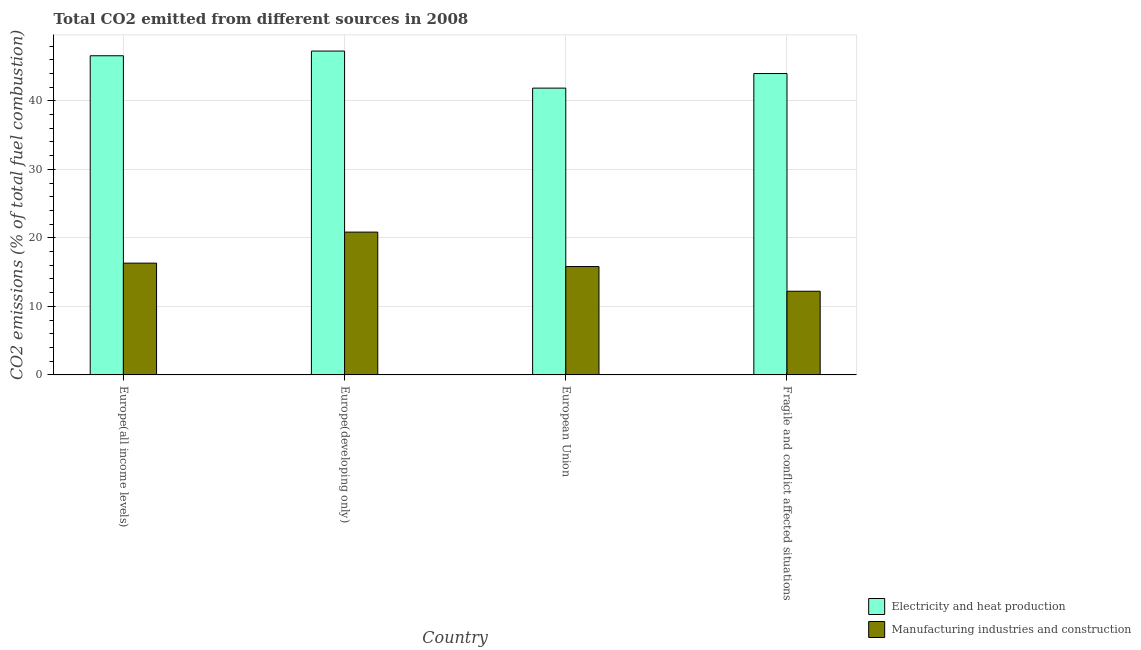How many different coloured bars are there?
Keep it short and to the point. 2. How many groups of bars are there?
Give a very brief answer. 4. Are the number of bars per tick equal to the number of legend labels?
Ensure brevity in your answer.  Yes. Are the number of bars on each tick of the X-axis equal?
Provide a succinct answer. Yes. How many bars are there on the 4th tick from the left?
Provide a succinct answer. 2. What is the label of the 2nd group of bars from the left?
Provide a succinct answer. Europe(developing only). What is the co2 emissions due to manufacturing industries in European Union?
Ensure brevity in your answer.  15.81. Across all countries, what is the maximum co2 emissions due to manufacturing industries?
Provide a succinct answer. 20.84. Across all countries, what is the minimum co2 emissions due to manufacturing industries?
Offer a very short reply. 12.21. In which country was the co2 emissions due to electricity and heat production maximum?
Make the answer very short. Europe(developing only). What is the total co2 emissions due to manufacturing industries in the graph?
Your response must be concise. 65.18. What is the difference between the co2 emissions due to electricity and heat production in Europe(all income levels) and that in European Union?
Provide a succinct answer. 4.72. What is the difference between the co2 emissions due to manufacturing industries in European Union and the co2 emissions due to electricity and heat production in Europe(developing only)?
Offer a terse response. -31.45. What is the average co2 emissions due to manufacturing industries per country?
Offer a terse response. 16.3. What is the difference between the co2 emissions due to electricity and heat production and co2 emissions due to manufacturing industries in Fragile and conflict affected situations?
Give a very brief answer. 31.77. What is the ratio of the co2 emissions due to electricity and heat production in Europe(all income levels) to that in Fragile and conflict affected situations?
Your answer should be compact. 1.06. What is the difference between the highest and the second highest co2 emissions due to electricity and heat production?
Offer a terse response. 0.68. What is the difference between the highest and the lowest co2 emissions due to manufacturing industries?
Provide a short and direct response. 8.63. In how many countries, is the co2 emissions due to electricity and heat production greater than the average co2 emissions due to electricity and heat production taken over all countries?
Your response must be concise. 2. Is the sum of the co2 emissions due to manufacturing industries in Europe(all income levels) and Europe(developing only) greater than the maximum co2 emissions due to electricity and heat production across all countries?
Keep it short and to the point. No. What does the 2nd bar from the left in Europe(developing only) represents?
Provide a succinct answer. Manufacturing industries and construction. What does the 1st bar from the right in Europe(all income levels) represents?
Make the answer very short. Manufacturing industries and construction. Does the graph contain grids?
Offer a very short reply. Yes. Where does the legend appear in the graph?
Give a very brief answer. Bottom right. How are the legend labels stacked?
Your answer should be compact. Vertical. What is the title of the graph?
Provide a succinct answer. Total CO2 emitted from different sources in 2008. What is the label or title of the Y-axis?
Offer a very short reply. CO2 emissions (% of total fuel combustion). What is the CO2 emissions (% of total fuel combustion) in Electricity and heat production in Europe(all income levels)?
Provide a short and direct response. 46.58. What is the CO2 emissions (% of total fuel combustion) of Manufacturing industries and construction in Europe(all income levels)?
Keep it short and to the point. 16.31. What is the CO2 emissions (% of total fuel combustion) of Electricity and heat production in Europe(developing only)?
Your answer should be compact. 47.26. What is the CO2 emissions (% of total fuel combustion) of Manufacturing industries and construction in Europe(developing only)?
Offer a terse response. 20.84. What is the CO2 emissions (% of total fuel combustion) of Electricity and heat production in European Union?
Provide a short and direct response. 41.86. What is the CO2 emissions (% of total fuel combustion) of Manufacturing industries and construction in European Union?
Give a very brief answer. 15.81. What is the CO2 emissions (% of total fuel combustion) of Electricity and heat production in Fragile and conflict affected situations?
Keep it short and to the point. 43.98. What is the CO2 emissions (% of total fuel combustion) of Manufacturing industries and construction in Fragile and conflict affected situations?
Your answer should be very brief. 12.21. Across all countries, what is the maximum CO2 emissions (% of total fuel combustion) of Electricity and heat production?
Your answer should be very brief. 47.26. Across all countries, what is the maximum CO2 emissions (% of total fuel combustion) of Manufacturing industries and construction?
Your answer should be very brief. 20.84. Across all countries, what is the minimum CO2 emissions (% of total fuel combustion) of Electricity and heat production?
Ensure brevity in your answer.  41.86. Across all countries, what is the minimum CO2 emissions (% of total fuel combustion) of Manufacturing industries and construction?
Offer a very short reply. 12.21. What is the total CO2 emissions (% of total fuel combustion) of Electricity and heat production in the graph?
Make the answer very short. 179.68. What is the total CO2 emissions (% of total fuel combustion) in Manufacturing industries and construction in the graph?
Your answer should be compact. 65.18. What is the difference between the CO2 emissions (% of total fuel combustion) of Electricity and heat production in Europe(all income levels) and that in Europe(developing only)?
Make the answer very short. -0.69. What is the difference between the CO2 emissions (% of total fuel combustion) in Manufacturing industries and construction in Europe(all income levels) and that in Europe(developing only)?
Provide a short and direct response. -4.53. What is the difference between the CO2 emissions (% of total fuel combustion) of Electricity and heat production in Europe(all income levels) and that in European Union?
Provide a succinct answer. 4.72. What is the difference between the CO2 emissions (% of total fuel combustion) of Manufacturing industries and construction in Europe(all income levels) and that in European Union?
Offer a terse response. 0.5. What is the difference between the CO2 emissions (% of total fuel combustion) of Electricity and heat production in Europe(all income levels) and that in Fragile and conflict affected situations?
Your response must be concise. 2.6. What is the difference between the CO2 emissions (% of total fuel combustion) in Manufacturing industries and construction in Europe(all income levels) and that in Fragile and conflict affected situations?
Keep it short and to the point. 4.1. What is the difference between the CO2 emissions (% of total fuel combustion) of Electricity and heat production in Europe(developing only) and that in European Union?
Provide a short and direct response. 5.41. What is the difference between the CO2 emissions (% of total fuel combustion) in Manufacturing industries and construction in Europe(developing only) and that in European Union?
Ensure brevity in your answer.  5.03. What is the difference between the CO2 emissions (% of total fuel combustion) of Electricity and heat production in Europe(developing only) and that in Fragile and conflict affected situations?
Offer a very short reply. 3.28. What is the difference between the CO2 emissions (% of total fuel combustion) of Manufacturing industries and construction in Europe(developing only) and that in Fragile and conflict affected situations?
Offer a very short reply. 8.63. What is the difference between the CO2 emissions (% of total fuel combustion) of Electricity and heat production in European Union and that in Fragile and conflict affected situations?
Keep it short and to the point. -2.13. What is the difference between the CO2 emissions (% of total fuel combustion) of Manufacturing industries and construction in European Union and that in Fragile and conflict affected situations?
Provide a short and direct response. 3.6. What is the difference between the CO2 emissions (% of total fuel combustion) in Electricity and heat production in Europe(all income levels) and the CO2 emissions (% of total fuel combustion) in Manufacturing industries and construction in Europe(developing only)?
Provide a short and direct response. 25.74. What is the difference between the CO2 emissions (% of total fuel combustion) in Electricity and heat production in Europe(all income levels) and the CO2 emissions (% of total fuel combustion) in Manufacturing industries and construction in European Union?
Your response must be concise. 30.77. What is the difference between the CO2 emissions (% of total fuel combustion) in Electricity and heat production in Europe(all income levels) and the CO2 emissions (% of total fuel combustion) in Manufacturing industries and construction in Fragile and conflict affected situations?
Your response must be concise. 34.37. What is the difference between the CO2 emissions (% of total fuel combustion) of Electricity and heat production in Europe(developing only) and the CO2 emissions (% of total fuel combustion) of Manufacturing industries and construction in European Union?
Your answer should be very brief. 31.45. What is the difference between the CO2 emissions (% of total fuel combustion) of Electricity and heat production in Europe(developing only) and the CO2 emissions (% of total fuel combustion) of Manufacturing industries and construction in Fragile and conflict affected situations?
Offer a terse response. 35.05. What is the difference between the CO2 emissions (% of total fuel combustion) in Electricity and heat production in European Union and the CO2 emissions (% of total fuel combustion) in Manufacturing industries and construction in Fragile and conflict affected situations?
Provide a succinct answer. 29.64. What is the average CO2 emissions (% of total fuel combustion) of Electricity and heat production per country?
Your response must be concise. 44.92. What is the average CO2 emissions (% of total fuel combustion) of Manufacturing industries and construction per country?
Keep it short and to the point. 16.3. What is the difference between the CO2 emissions (% of total fuel combustion) in Electricity and heat production and CO2 emissions (% of total fuel combustion) in Manufacturing industries and construction in Europe(all income levels)?
Keep it short and to the point. 30.26. What is the difference between the CO2 emissions (% of total fuel combustion) of Electricity and heat production and CO2 emissions (% of total fuel combustion) of Manufacturing industries and construction in Europe(developing only)?
Ensure brevity in your answer.  26.42. What is the difference between the CO2 emissions (% of total fuel combustion) in Electricity and heat production and CO2 emissions (% of total fuel combustion) in Manufacturing industries and construction in European Union?
Your answer should be compact. 26.04. What is the difference between the CO2 emissions (% of total fuel combustion) of Electricity and heat production and CO2 emissions (% of total fuel combustion) of Manufacturing industries and construction in Fragile and conflict affected situations?
Your answer should be compact. 31.77. What is the ratio of the CO2 emissions (% of total fuel combustion) in Electricity and heat production in Europe(all income levels) to that in Europe(developing only)?
Make the answer very short. 0.99. What is the ratio of the CO2 emissions (% of total fuel combustion) in Manufacturing industries and construction in Europe(all income levels) to that in Europe(developing only)?
Your answer should be very brief. 0.78. What is the ratio of the CO2 emissions (% of total fuel combustion) of Electricity and heat production in Europe(all income levels) to that in European Union?
Keep it short and to the point. 1.11. What is the ratio of the CO2 emissions (% of total fuel combustion) of Manufacturing industries and construction in Europe(all income levels) to that in European Union?
Make the answer very short. 1.03. What is the ratio of the CO2 emissions (% of total fuel combustion) in Electricity and heat production in Europe(all income levels) to that in Fragile and conflict affected situations?
Your answer should be compact. 1.06. What is the ratio of the CO2 emissions (% of total fuel combustion) in Manufacturing industries and construction in Europe(all income levels) to that in Fragile and conflict affected situations?
Keep it short and to the point. 1.34. What is the ratio of the CO2 emissions (% of total fuel combustion) in Electricity and heat production in Europe(developing only) to that in European Union?
Your response must be concise. 1.13. What is the ratio of the CO2 emissions (% of total fuel combustion) in Manufacturing industries and construction in Europe(developing only) to that in European Union?
Ensure brevity in your answer.  1.32. What is the ratio of the CO2 emissions (% of total fuel combustion) in Electricity and heat production in Europe(developing only) to that in Fragile and conflict affected situations?
Your answer should be very brief. 1.07. What is the ratio of the CO2 emissions (% of total fuel combustion) of Manufacturing industries and construction in Europe(developing only) to that in Fragile and conflict affected situations?
Your response must be concise. 1.71. What is the ratio of the CO2 emissions (% of total fuel combustion) in Electricity and heat production in European Union to that in Fragile and conflict affected situations?
Keep it short and to the point. 0.95. What is the ratio of the CO2 emissions (% of total fuel combustion) in Manufacturing industries and construction in European Union to that in Fragile and conflict affected situations?
Make the answer very short. 1.29. What is the difference between the highest and the second highest CO2 emissions (% of total fuel combustion) of Electricity and heat production?
Your response must be concise. 0.69. What is the difference between the highest and the second highest CO2 emissions (% of total fuel combustion) in Manufacturing industries and construction?
Offer a terse response. 4.53. What is the difference between the highest and the lowest CO2 emissions (% of total fuel combustion) of Electricity and heat production?
Offer a terse response. 5.41. What is the difference between the highest and the lowest CO2 emissions (% of total fuel combustion) of Manufacturing industries and construction?
Provide a succinct answer. 8.63. 